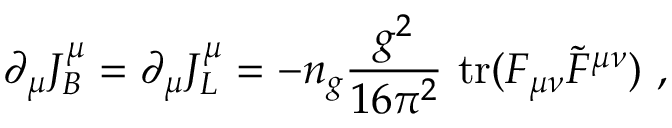<formula> <loc_0><loc_0><loc_500><loc_500>\partial _ { \mu } J _ { B } ^ { \mu } = \partial _ { \mu } J _ { L } ^ { \mu } = - n _ { g } \frac { g ^ { 2 } } { 1 6 \pi ^ { 2 } } { t r } ( F _ { \mu \nu } \tilde { F } ^ { \mu \nu } ) ,</formula> 